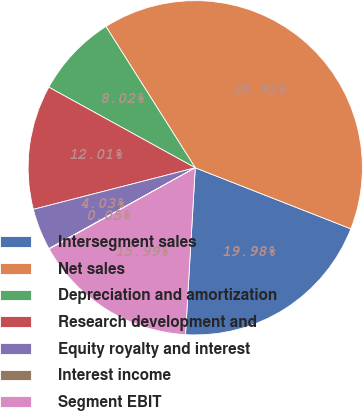Convert chart to OTSL. <chart><loc_0><loc_0><loc_500><loc_500><pie_chart><fcel>Intersegment sales<fcel>Net sales<fcel>Depreciation and amortization<fcel>Research development and<fcel>Equity royalty and interest<fcel>Interest income<fcel>Segment EBIT<nl><fcel>19.98%<fcel>39.92%<fcel>8.02%<fcel>12.01%<fcel>4.03%<fcel>0.05%<fcel>15.99%<nl></chart> 